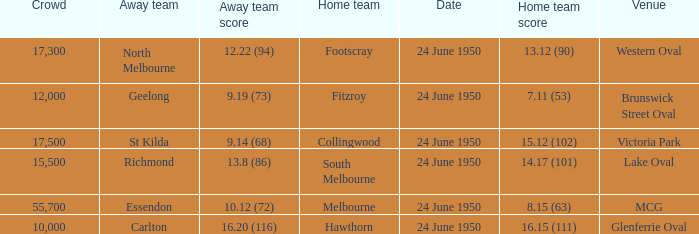When was the event where the away team achieved a score of 1 24 June 1950. 